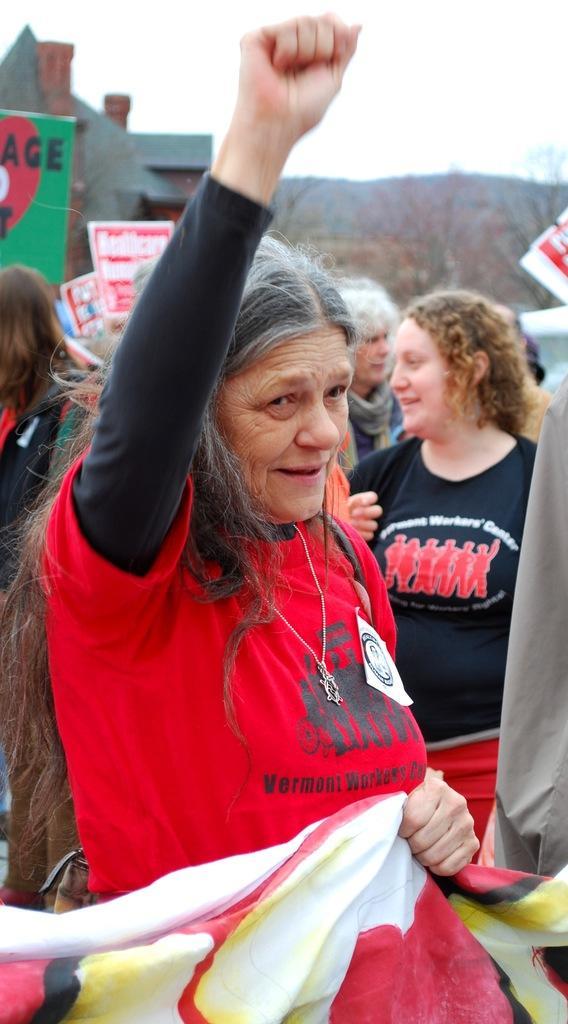Describe this image in one or two sentences. In the center of the image we can see a woman wearing red t shirt and holding the cloth. In the background we can see some people and also text boards and house and trees. Sky is also visible. 